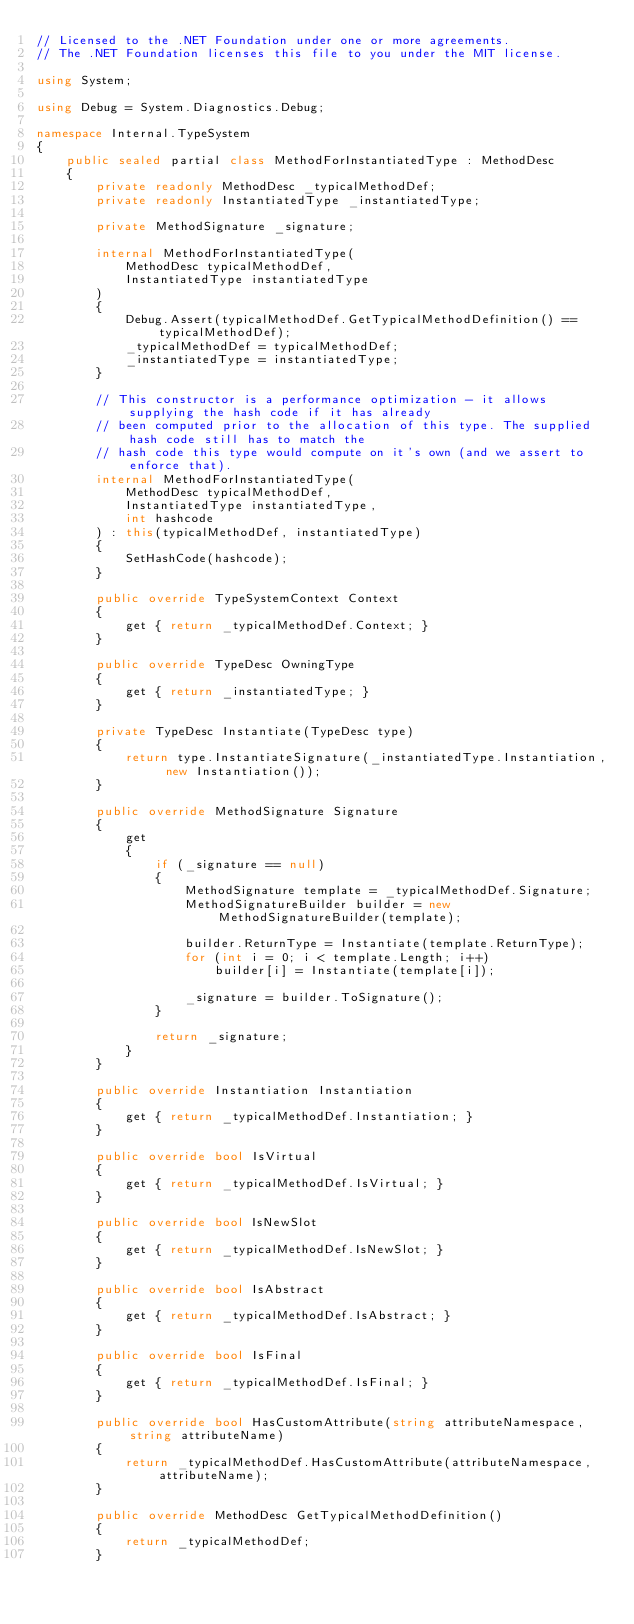Convert code to text. <code><loc_0><loc_0><loc_500><loc_500><_C#_>// Licensed to the .NET Foundation under one or more agreements.
// The .NET Foundation licenses this file to you under the MIT license.

using System;

using Debug = System.Diagnostics.Debug;

namespace Internal.TypeSystem
{
    public sealed partial class MethodForInstantiatedType : MethodDesc
    {
        private readonly MethodDesc _typicalMethodDef;
        private readonly InstantiatedType _instantiatedType;

        private MethodSignature _signature;

        internal MethodForInstantiatedType(
            MethodDesc typicalMethodDef,
            InstantiatedType instantiatedType
        )
        {
            Debug.Assert(typicalMethodDef.GetTypicalMethodDefinition() == typicalMethodDef);
            _typicalMethodDef = typicalMethodDef;
            _instantiatedType = instantiatedType;
        }

        // This constructor is a performance optimization - it allows supplying the hash code if it has already
        // been computed prior to the allocation of this type. The supplied hash code still has to match the
        // hash code this type would compute on it's own (and we assert to enforce that).
        internal MethodForInstantiatedType(
            MethodDesc typicalMethodDef,
            InstantiatedType instantiatedType,
            int hashcode
        ) : this(typicalMethodDef, instantiatedType)
        {
            SetHashCode(hashcode);
        }

        public override TypeSystemContext Context
        {
            get { return _typicalMethodDef.Context; }
        }

        public override TypeDesc OwningType
        {
            get { return _instantiatedType; }
        }

        private TypeDesc Instantiate(TypeDesc type)
        {
            return type.InstantiateSignature(_instantiatedType.Instantiation, new Instantiation());
        }

        public override MethodSignature Signature
        {
            get
            {
                if (_signature == null)
                {
                    MethodSignature template = _typicalMethodDef.Signature;
                    MethodSignatureBuilder builder = new MethodSignatureBuilder(template);

                    builder.ReturnType = Instantiate(template.ReturnType);
                    for (int i = 0; i < template.Length; i++)
                        builder[i] = Instantiate(template[i]);

                    _signature = builder.ToSignature();
                }

                return _signature;
            }
        }

        public override Instantiation Instantiation
        {
            get { return _typicalMethodDef.Instantiation; }
        }

        public override bool IsVirtual
        {
            get { return _typicalMethodDef.IsVirtual; }
        }

        public override bool IsNewSlot
        {
            get { return _typicalMethodDef.IsNewSlot; }
        }

        public override bool IsAbstract
        {
            get { return _typicalMethodDef.IsAbstract; }
        }

        public override bool IsFinal
        {
            get { return _typicalMethodDef.IsFinal; }
        }

        public override bool HasCustomAttribute(string attributeNamespace, string attributeName)
        {
            return _typicalMethodDef.HasCustomAttribute(attributeNamespace, attributeName);
        }

        public override MethodDesc GetTypicalMethodDefinition()
        {
            return _typicalMethodDef;
        }
</code> 